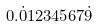<formula> <loc_0><loc_0><loc_500><loc_500>0 . { \dot { 0 } } 1 2 3 4 5 6 7 { \dot { 9 } }</formula> 